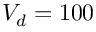Convert formula to latex. <formula><loc_0><loc_0><loc_500><loc_500>V _ { d } = 1 0 0</formula> 